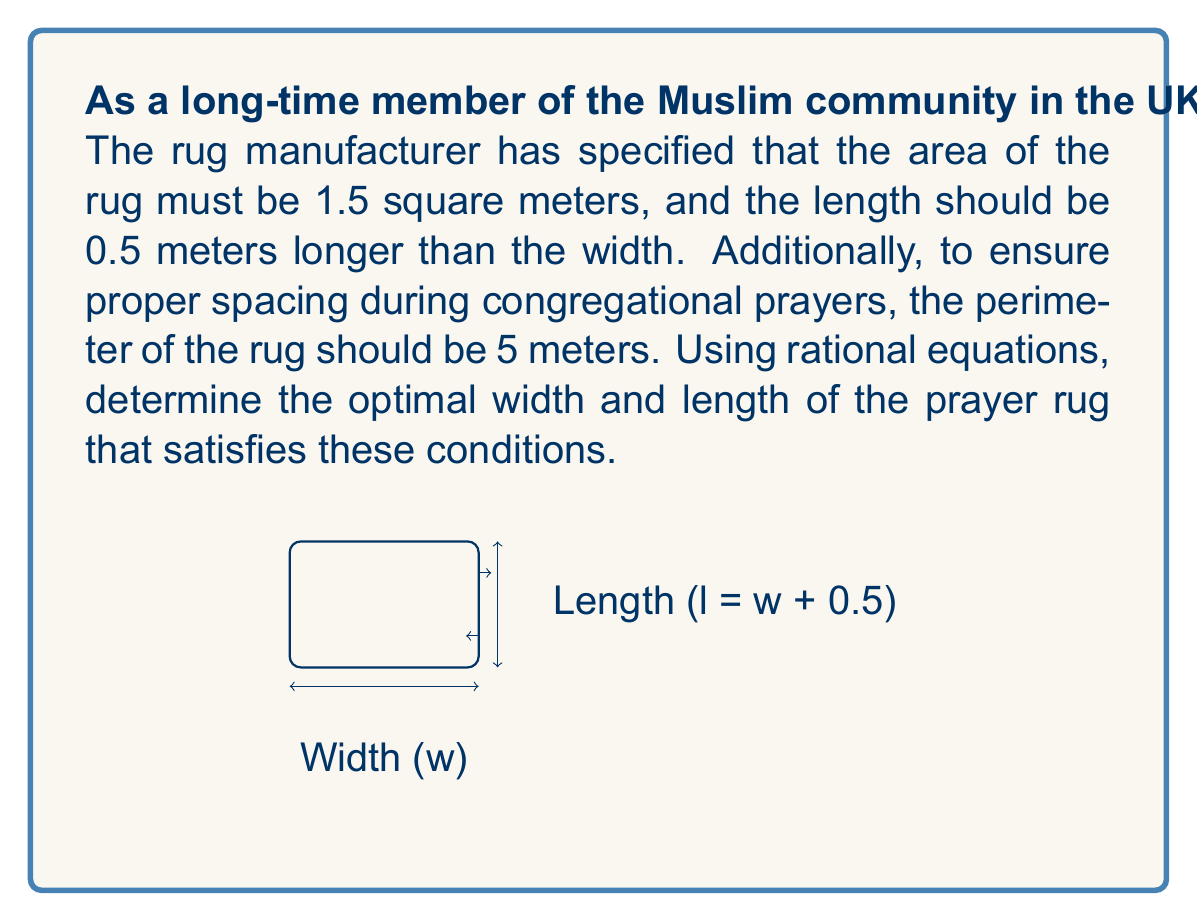Can you answer this question? Let's approach this step-by-step using rational equations:

1) Let w be the width of the rug. Then, the length l is w + 0.5.

2) The area condition gives us:
   $$ w(w + 0.5) = 1.5 $$

3) The perimeter condition gives us:
   $$ 2w + 2(w + 0.5) = 5 $$

4) Simplify the perimeter equation:
   $$ 4w + 1 = 5 $$
   $$ 4w = 4 $$
   $$ w = 1 $$

5) Now, substitute w = 1 into the area equation to verify:
   $$ 1(1 + 0.5) = 1.5 $$
   $$ 1.5 = 1.5 $$

6) This satisfies both conditions. Therefore, the width is 1 meter.

7) The length is w + 0.5 = 1 + 0.5 = 1.5 meters.

We can verify that the perimeter is indeed 5 meters:
$$ 2(1) + 2(1.5) = 2 + 3 = 5 $$

And the area is 1.5 square meters:
$$ 1 * 1.5 = 1.5 $$
Answer: Width: 1 m, Length: 1.5 m 